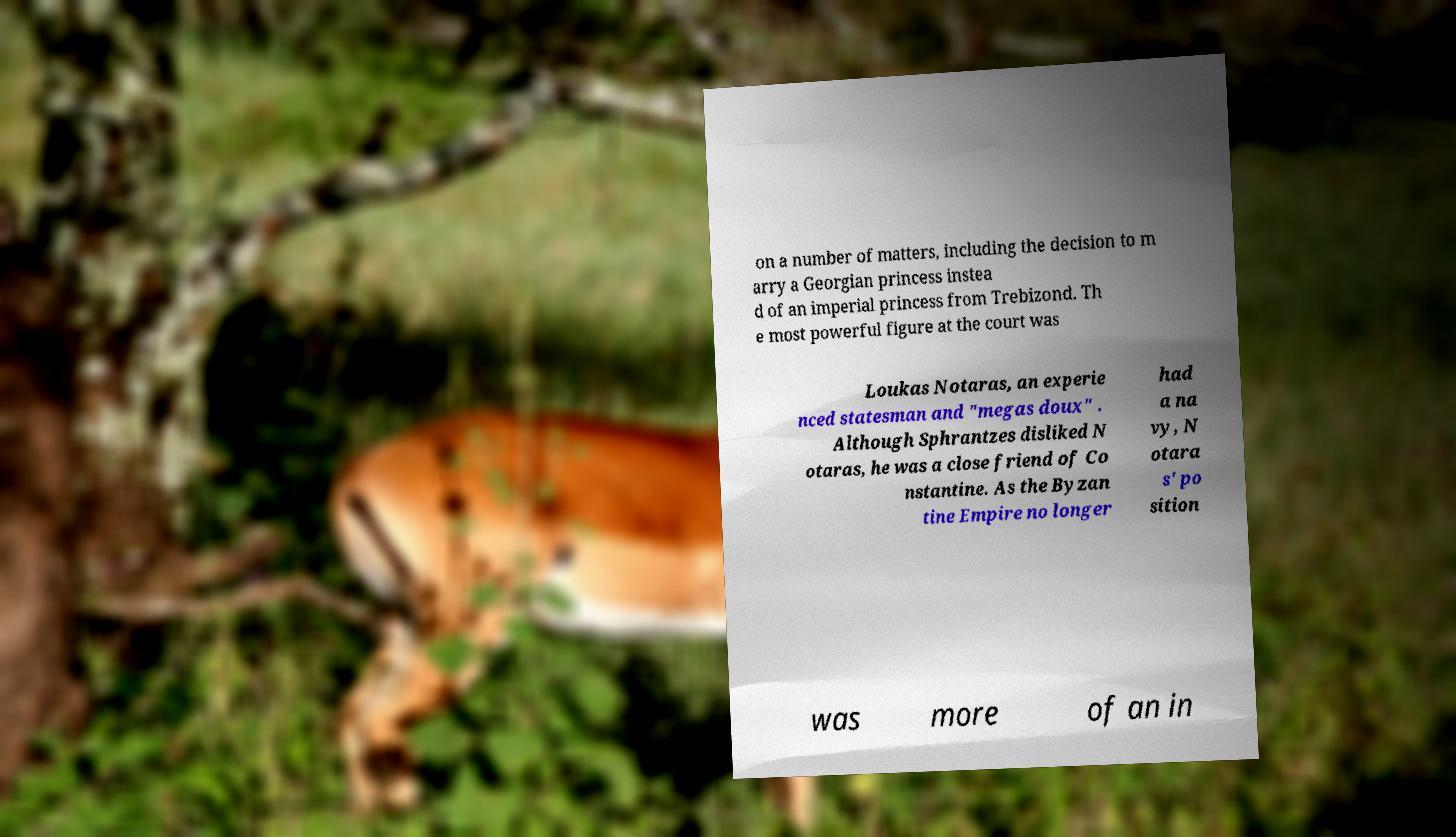Could you extract and type out the text from this image? on a number of matters, including the decision to m arry a Georgian princess instea d of an imperial princess from Trebizond. Th e most powerful figure at the court was Loukas Notaras, an experie nced statesman and "megas doux" . Although Sphrantzes disliked N otaras, he was a close friend of Co nstantine. As the Byzan tine Empire no longer had a na vy, N otara s' po sition was more of an in 